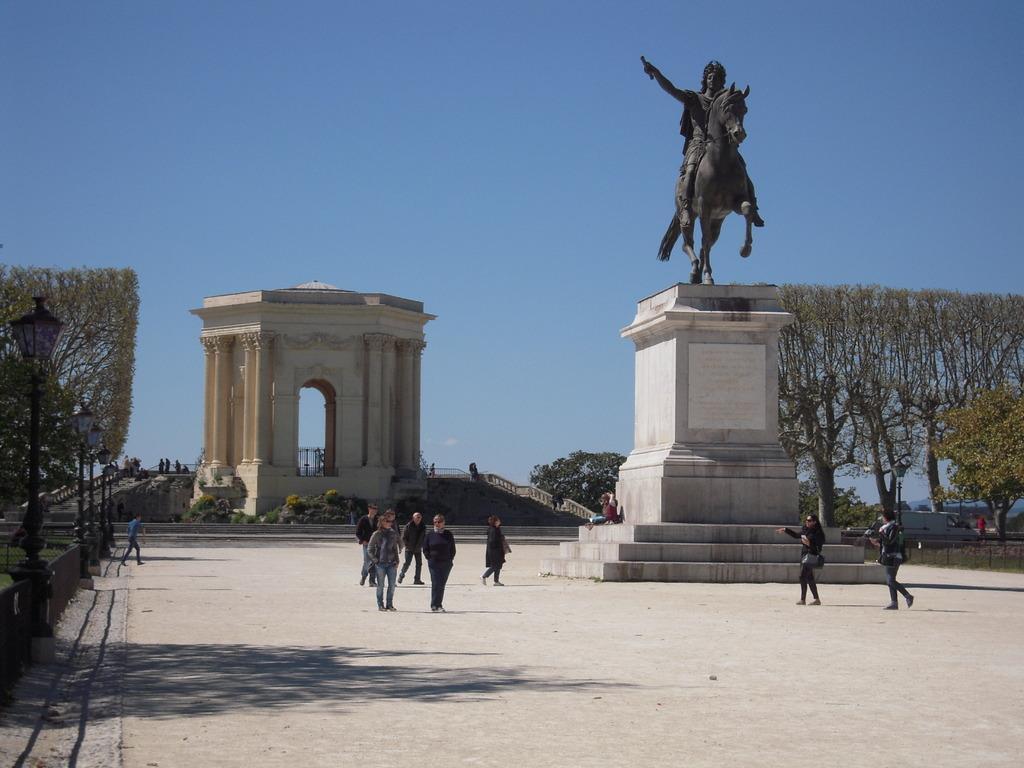Please provide a concise description of this image. In this image we can see some people walking on the ground. On the right side we can see a statue, poles and a group of trees. On the left side we can see some street lamps and plants. On the backside we can see a monument with stairs and pillars and the sky which looks cloudy. 